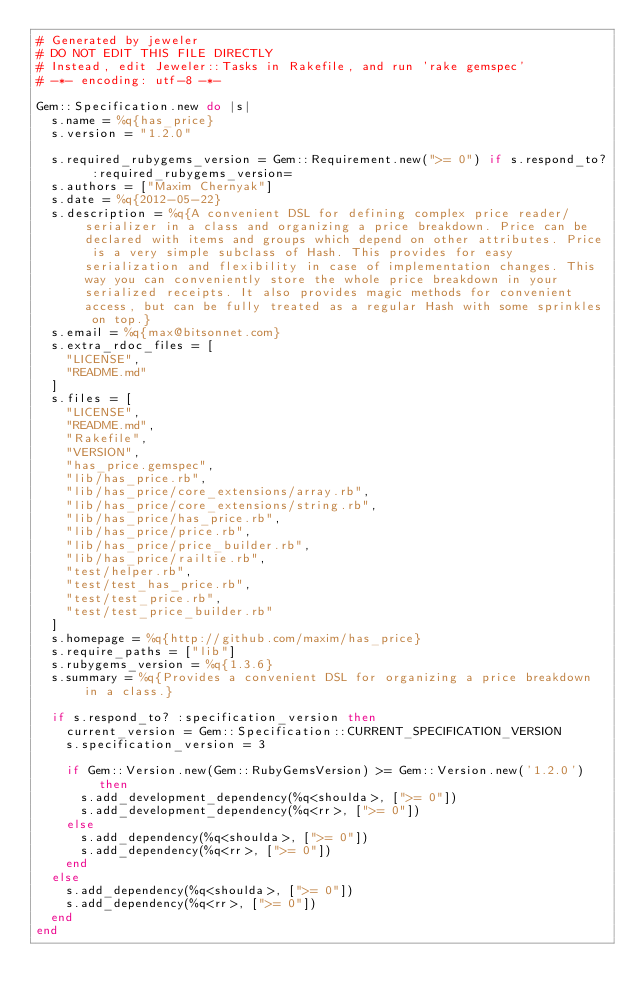Convert code to text. <code><loc_0><loc_0><loc_500><loc_500><_Ruby_># Generated by jeweler
# DO NOT EDIT THIS FILE DIRECTLY
# Instead, edit Jeweler::Tasks in Rakefile, and run 'rake gemspec'
# -*- encoding: utf-8 -*-

Gem::Specification.new do |s|
  s.name = %q{has_price}
  s.version = "1.2.0"

  s.required_rubygems_version = Gem::Requirement.new(">= 0") if s.respond_to? :required_rubygems_version=
  s.authors = ["Maxim Chernyak"]
  s.date = %q{2012-05-22}
  s.description = %q{A convenient DSL for defining complex price reader/serializer in a class and organizing a price breakdown. Price can be declared with items and groups which depend on other attributes. Price is a very simple subclass of Hash. This provides for easy serialization and flexibility in case of implementation changes. This way you can conveniently store the whole price breakdown in your serialized receipts. It also provides magic methods for convenient access, but can be fully treated as a regular Hash with some sprinkles on top.}
  s.email = %q{max@bitsonnet.com}
  s.extra_rdoc_files = [
    "LICENSE",
    "README.md"
  ]
  s.files = [
    "LICENSE",
    "README.md",
    "Rakefile",
    "VERSION",
    "has_price.gemspec",
    "lib/has_price.rb",
    "lib/has_price/core_extensions/array.rb",
    "lib/has_price/core_extensions/string.rb",
    "lib/has_price/has_price.rb",
    "lib/has_price/price.rb",
    "lib/has_price/price_builder.rb",
    "lib/has_price/railtie.rb",
    "test/helper.rb",
    "test/test_has_price.rb",
    "test/test_price.rb",
    "test/test_price_builder.rb"
  ]
  s.homepage = %q{http://github.com/maxim/has_price}
  s.require_paths = ["lib"]
  s.rubygems_version = %q{1.3.6}
  s.summary = %q{Provides a convenient DSL for organizing a price breakdown in a class.}

  if s.respond_to? :specification_version then
    current_version = Gem::Specification::CURRENT_SPECIFICATION_VERSION
    s.specification_version = 3

    if Gem::Version.new(Gem::RubyGemsVersion) >= Gem::Version.new('1.2.0') then
      s.add_development_dependency(%q<shoulda>, [">= 0"])
      s.add_development_dependency(%q<rr>, [">= 0"])
    else
      s.add_dependency(%q<shoulda>, [">= 0"])
      s.add_dependency(%q<rr>, [">= 0"])
    end
  else
    s.add_dependency(%q<shoulda>, [">= 0"])
    s.add_dependency(%q<rr>, [">= 0"])
  end
end

</code> 